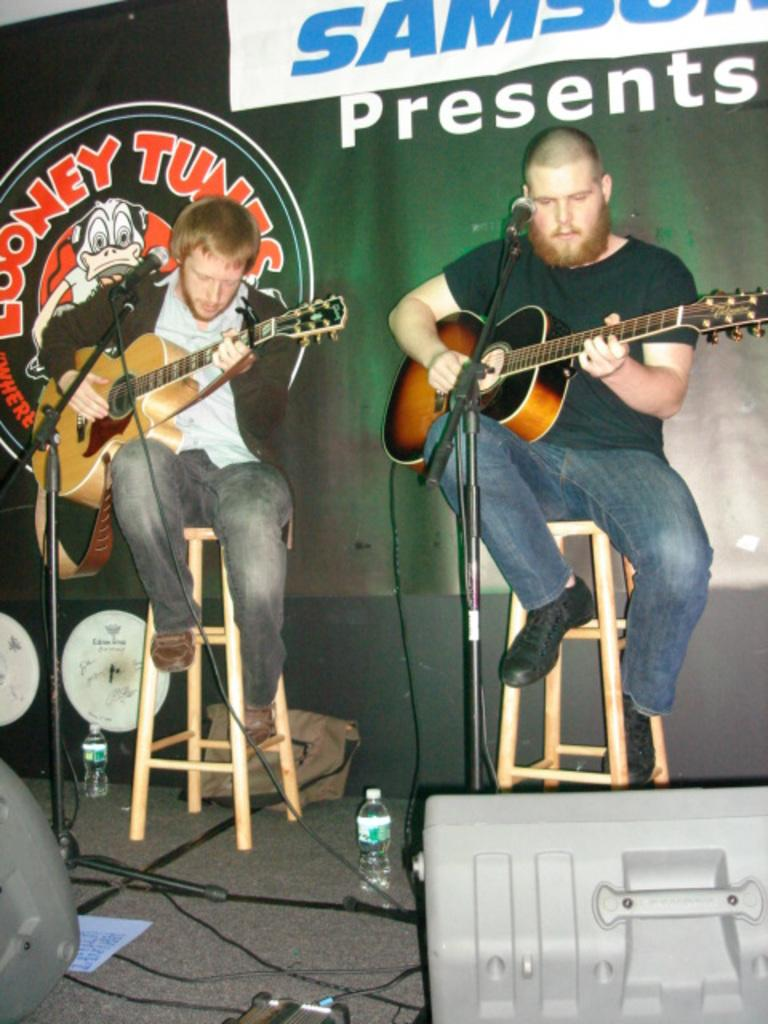How many people are in the image? There are two persons in the image. What are the two persons doing? The two persons are playing guitar. What object is in front of the persons? There is a microphone in front of the persons. What can be seen behind the persons? There is a banner behind the persons. What is written on the banner? Something is written on the banner, but we cannot determine the exact text from the image. Can you hear the noise made by the brother in the image? There is no brother present in the image, and we cannot hear any noise as it is a still image. 